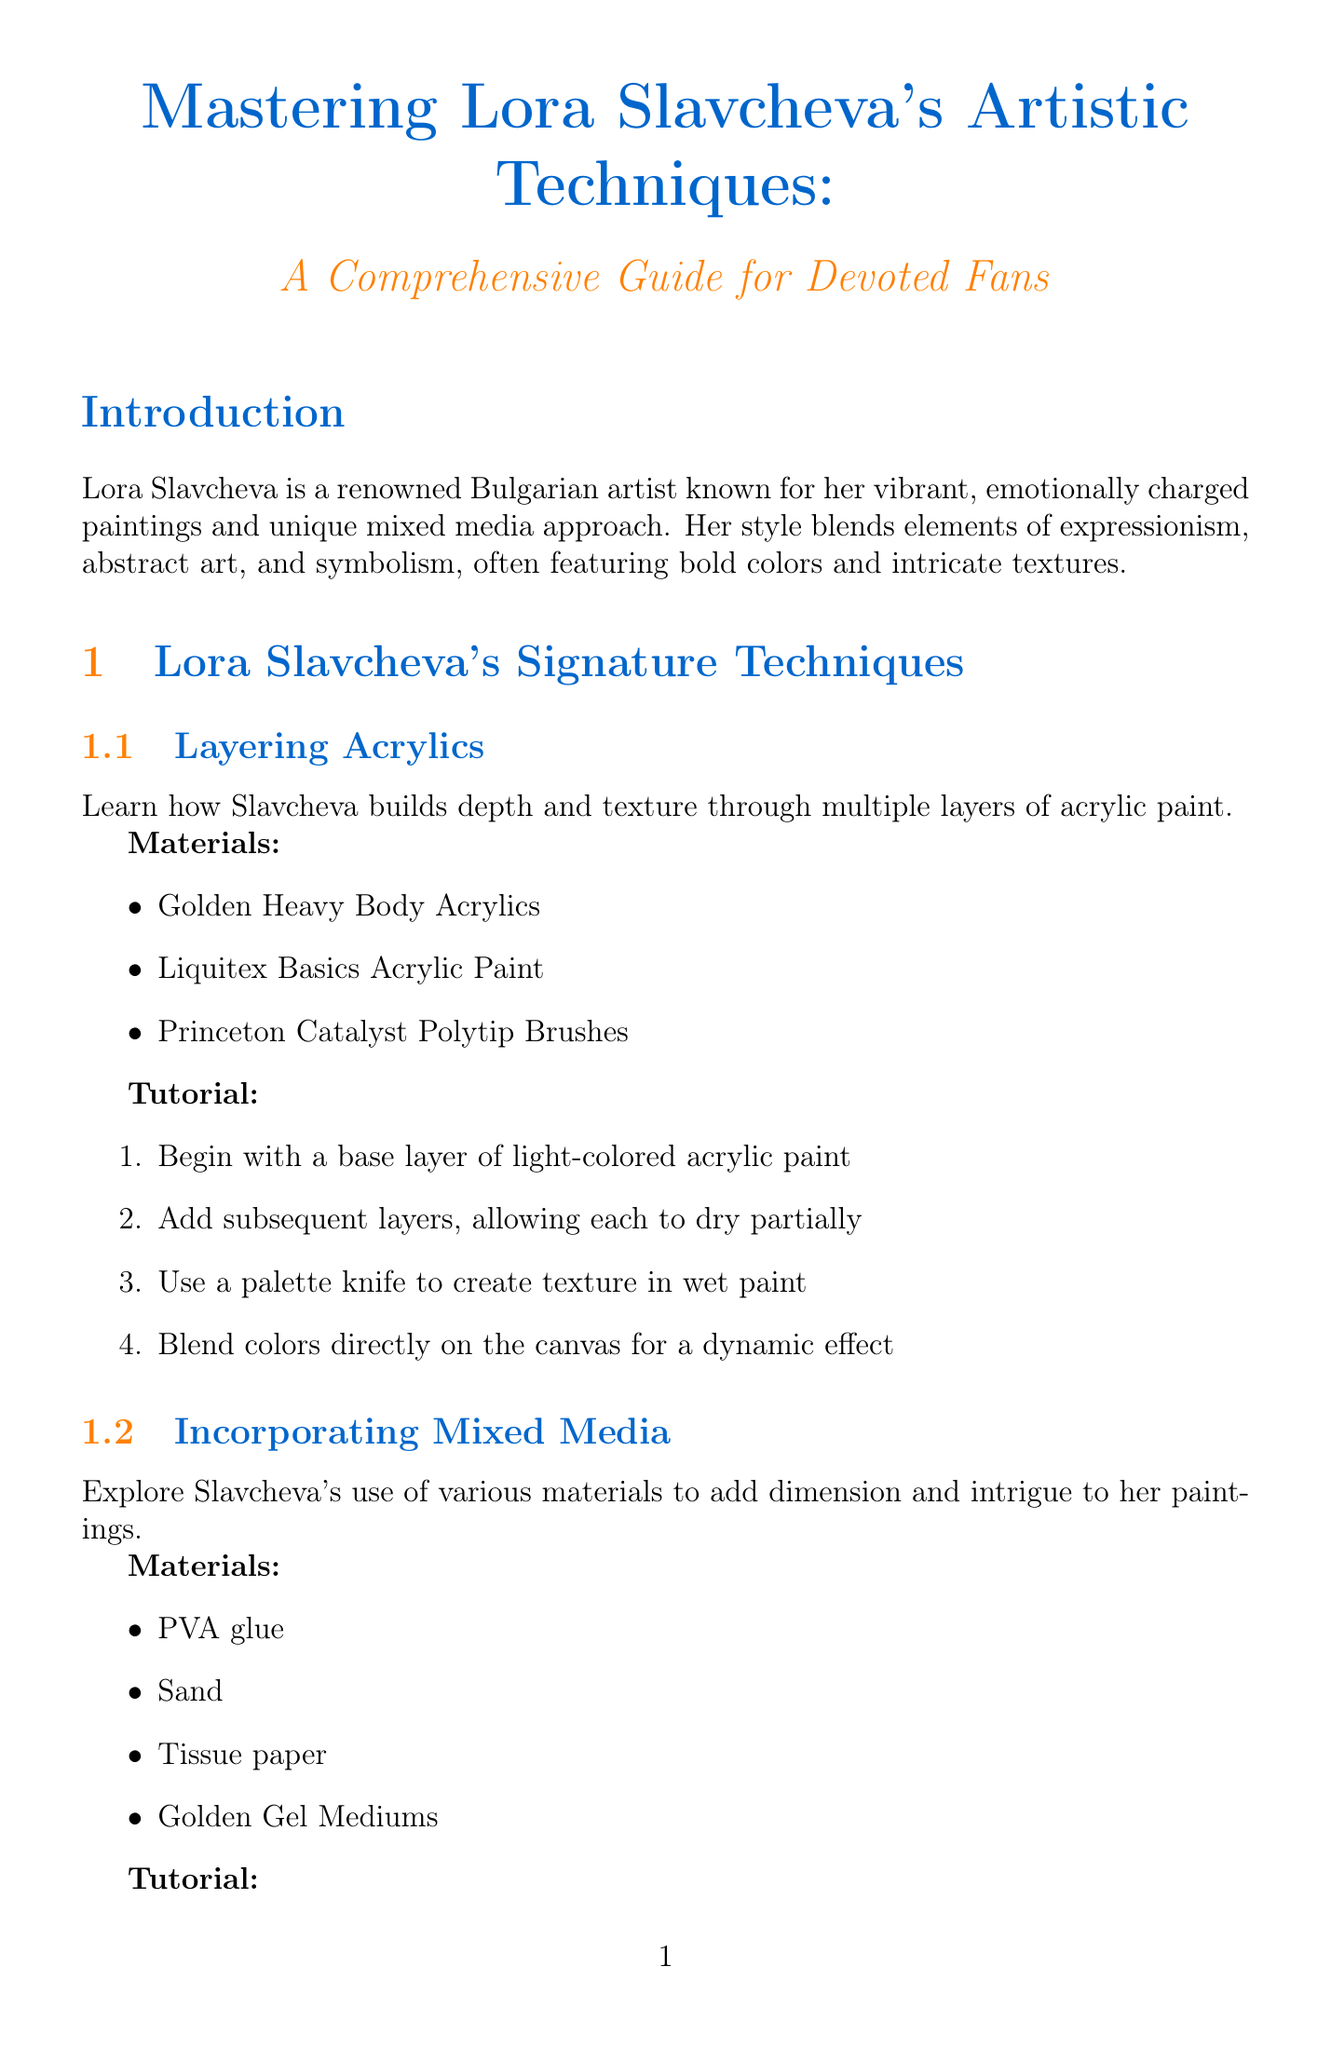What is the title of the manual? The title is found in the opening section of the document, which introduces the content.
Answer: Mastering Lora Slavcheva's Artistic Techniques: A Comprehensive Guide for Devoted Fans Who is Lora Slavcheva? The introduction describes Lora Slavcheva as a renowned artist, providing key information about her background.
Answer: A renowned Bulgarian artist What materials are recommended for Layering Acrylics? The materials for this technique are listed in the section dedicated to Layering Acrylics.
Answer: Golden Heavy Body Acrylics, Liquitex Basics Acrylic Paint, Princeton Catalyst Polytip Brushes How many steps are included in the Incorporating Mixed Media tutorial? The Incorporating Mixed Media section contains a tutorial with several step-by-step instructions.
Answer: Four steps What color combination suggests passion and introspection? The Emotional Color Psychology section provides details about paintings and their corresponding emotional impact based on color combinations.
Answer: Deep reds, Muted purples What exercise is suggested for exploring color palettes? The Vibrant Color Palettes section offers an exercise related to creating color wheels.
Answer: Create a color wheel inspired by Slavcheva's most frequent color choices What symbol represents freedom and spiritual transcendence? The Recurring Symbols section lists symbols and their meanings in Slavcheva's art.
Answer: Birds How many exercises are suggested for developing your own style? The Experimentation Techniques section enumerates various exercises to inspire personal artistic style.
Answer: Three exercises What should be documented to track artistic evolution? The Building a Body of Work section lists steps that include documentation as part of the artistic process.
Answer: Your process 